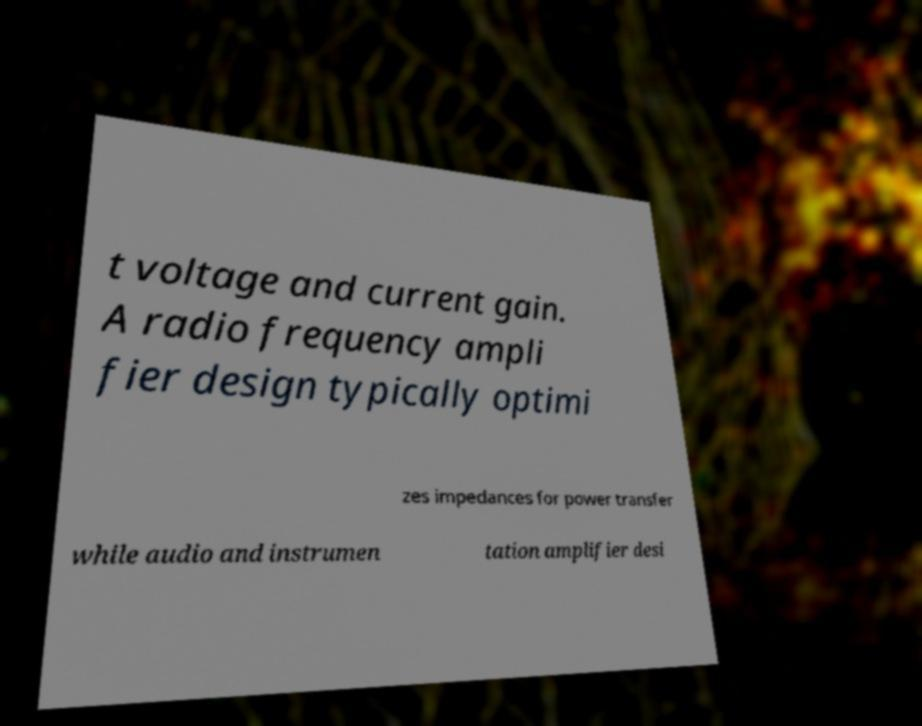There's text embedded in this image that I need extracted. Can you transcribe it verbatim? t voltage and current gain. A radio frequency ampli fier design typically optimi zes impedances for power transfer while audio and instrumen tation amplifier desi 